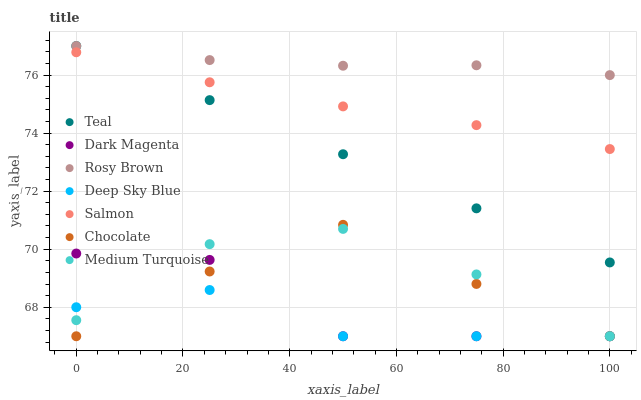Does Deep Sky Blue have the minimum area under the curve?
Answer yes or no. Yes. Does Rosy Brown have the maximum area under the curve?
Answer yes or no. Yes. Does Medium Turquoise have the minimum area under the curve?
Answer yes or no. No. Does Medium Turquoise have the maximum area under the curve?
Answer yes or no. No. Is Teal the smoothest?
Answer yes or no. Yes. Is Dark Magenta the roughest?
Answer yes or no. Yes. Is Medium Turquoise the smoothest?
Answer yes or no. No. Is Medium Turquoise the roughest?
Answer yes or no. No. Does Medium Turquoise have the lowest value?
Answer yes or no. Yes. Does Rosy Brown have the lowest value?
Answer yes or no. No. Does Rosy Brown have the highest value?
Answer yes or no. Yes. Does Medium Turquoise have the highest value?
Answer yes or no. No. Is Dark Magenta less than Salmon?
Answer yes or no. Yes. Is Teal greater than Dark Magenta?
Answer yes or no. Yes. Does Medium Turquoise intersect Dark Magenta?
Answer yes or no. Yes. Is Medium Turquoise less than Dark Magenta?
Answer yes or no. No. Is Medium Turquoise greater than Dark Magenta?
Answer yes or no. No. Does Dark Magenta intersect Salmon?
Answer yes or no. No. 